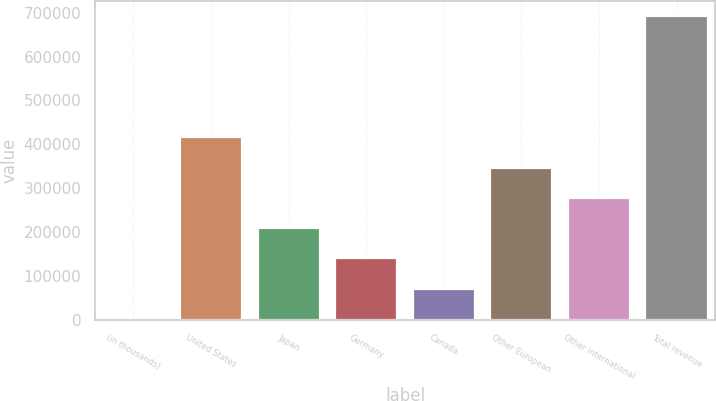Convert chart. <chart><loc_0><loc_0><loc_500><loc_500><bar_chart><fcel>(in thousands)<fcel>United States<fcel>Japan<fcel>Germany<fcel>Canada<fcel>Other European<fcel>Other international<fcel>Total revenue<nl><fcel>2011<fcel>415674<fcel>208842<fcel>139899<fcel>70954.8<fcel>346730<fcel>277786<fcel>691449<nl></chart> 